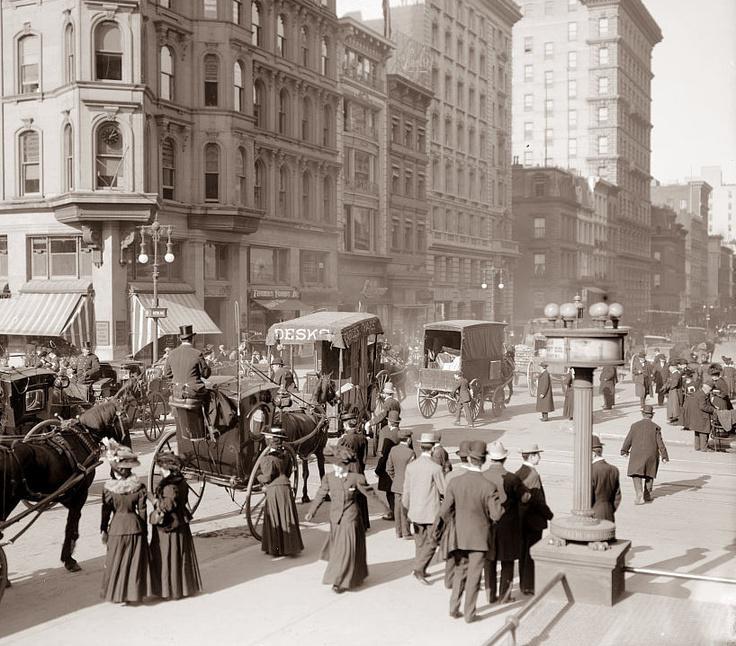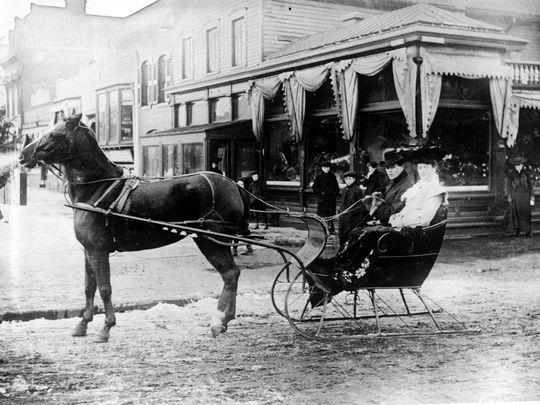The first image is the image on the left, the second image is the image on the right. Evaluate the accuracy of this statement regarding the images: "In the foreground of the right image, at least one dark horse is pulling a four-wheeled carriage driven by a man in a hat, suit and white shirt, holding a stick.". Is it true? Answer yes or no. No. 